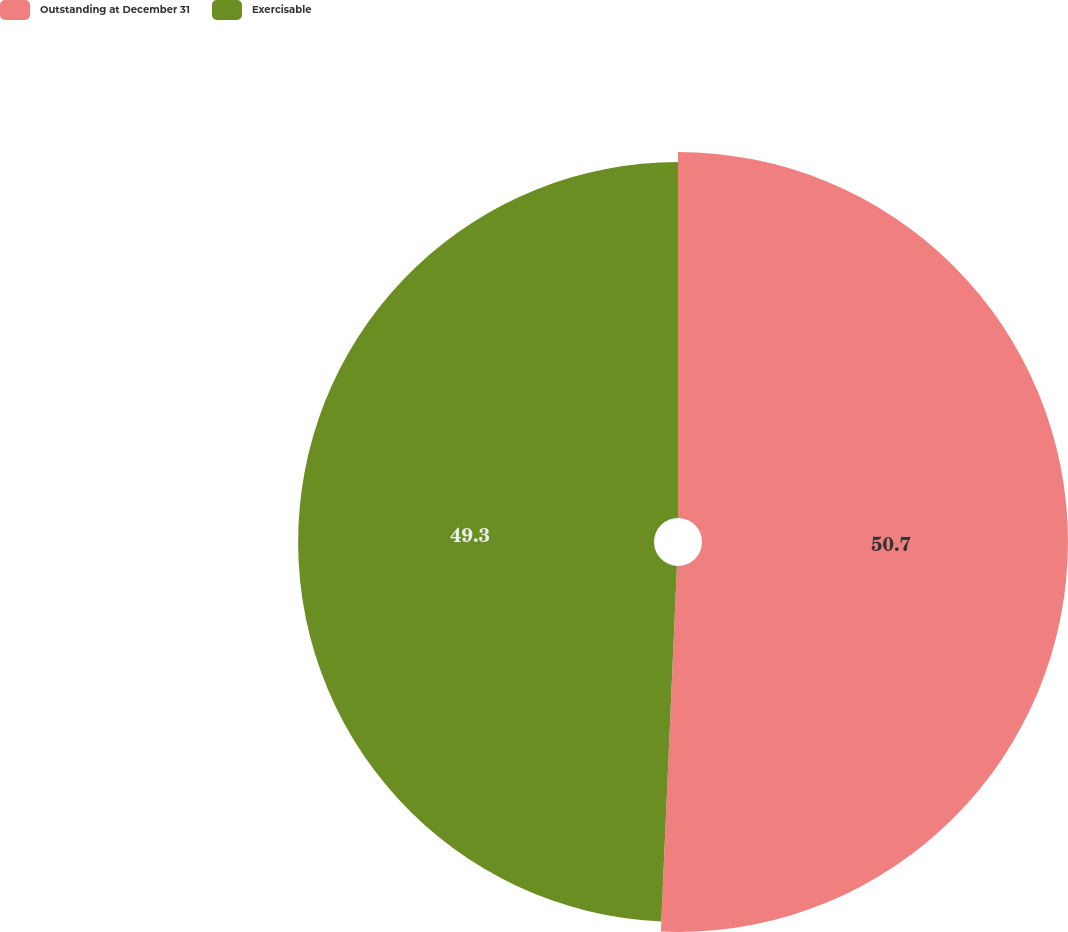Convert chart to OTSL. <chart><loc_0><loc_0><loc_500><loc_500><pie_chart><fcel>Outstanding at December 31<fcel>Exercisable<nl><fcel>50.7%<fcel>49.3%<nl></chart> 